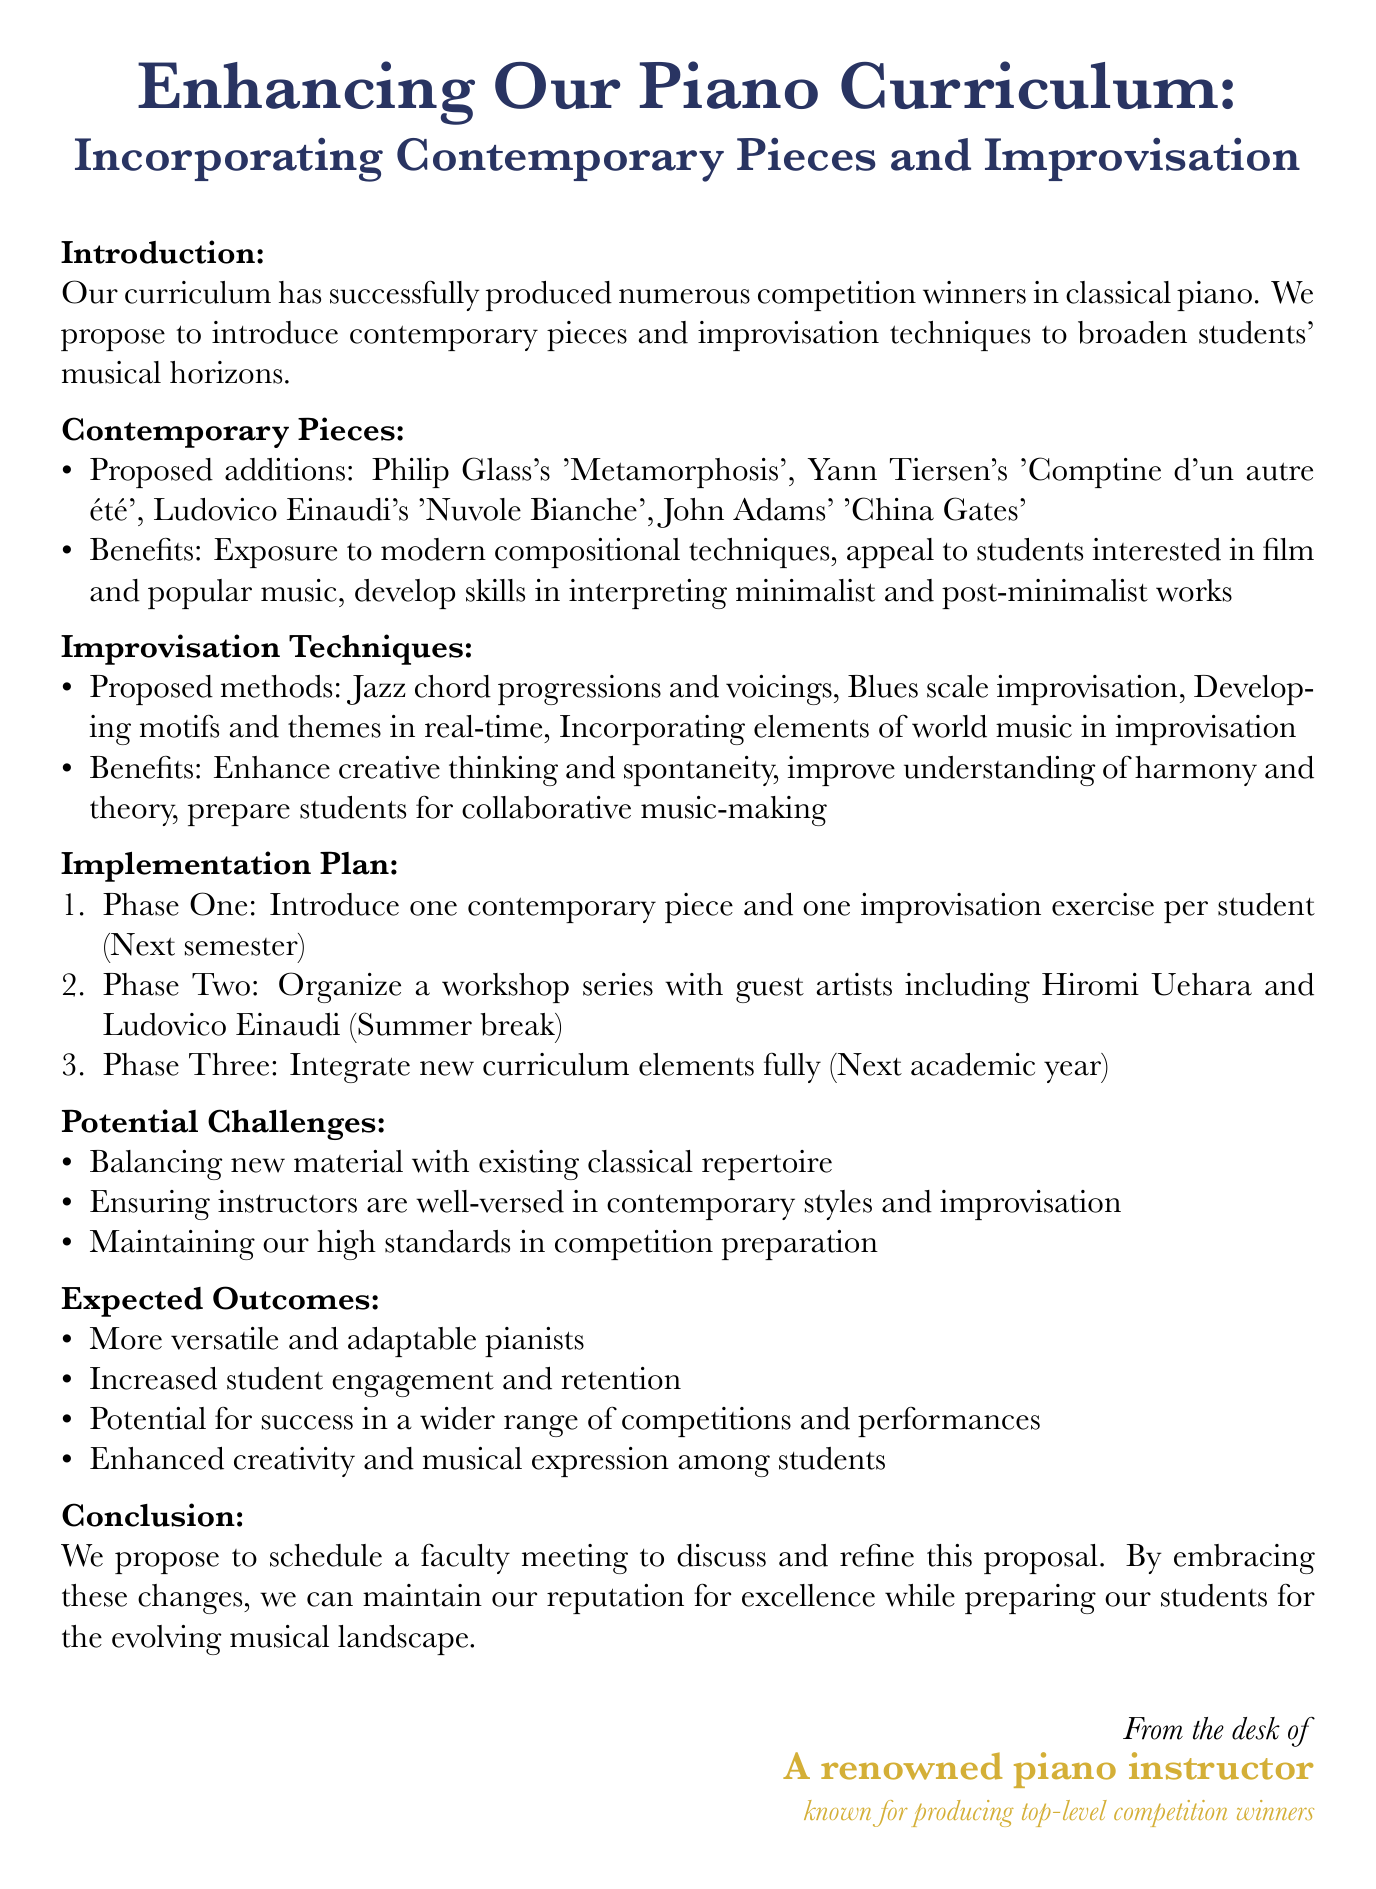What is the title of the memo? The title of the memo is stated clearly at the top of the document.
Answer: Enhancing Our Piano Curriculum: Incorporating Contemporary Pieces and Improvisation What are the proposed contemporary pieces? The proposed contemporary pieces are listed in a section of the memo.
Answer: Philip Glass's 'Metamorphosis', Yann Tiersen's 'Comptine d'un autre été', Ludovico Einaudi's 'Nuvole Bianche', John Adams' 'China Gates' What is the timeline for Phase One of the implementation plan? The timeline for Phase One is specified in the implementation plan section.
Answer: Next semester Who are the guest artists mentioned for the workshop series? The guest artists are explicitly listed in the implementation plan.
Answer: Hiromi Uehara, Ludovico Einaudi What is one potential challenge mentioned in the memo? The potential challenges are itemized in a specific section of the document.
Answer: Balancing new material with existing classical repertoire What is an expected outcome of the proposed curriculum adjustments? Expected outcomes are summarized in a list within the document.
Answer: More versatile and adaptable pianists How many phases are in the implementation plan? The implementation plan outlines the phases numbered distinctly.
Answer: Three What is the call to action in the conclusion? The conclusion contains a specific call to action for faculty.
Answer: Schedule a faculty meeting to discuss and refine this proposal 